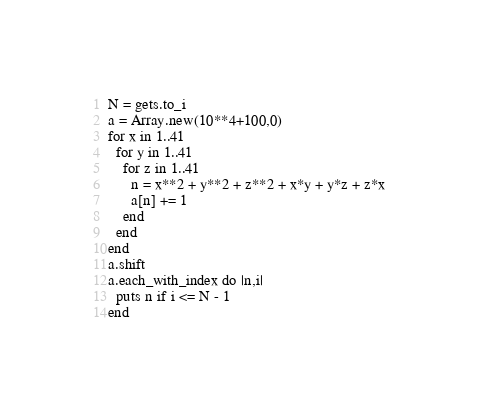<code> <loc_0><loc_0><loc_500><loc_500><_Ruby_>N = gets.to_i
a = Array.new(10**4+100,0)
for x in 1..41
  for y in 1..41
    for z in 1..41
      n = x**2 + y**2 + z**2 + x*y + y*z + z*x
      a[n] += 1
    end
  end
end
a.shift
a.each_with_index do |n,i|
  puts n if i <= N - 1
end
</code> 